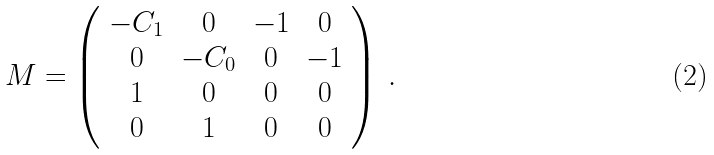Convert formula to latex. <formula><loc_0><loc_0><loc_500><loc_500>M = \left ( \begin{array} { c c c c } - C _ { 1 } & 0 & - 1 & 0 \\ 0 & - C _ { 0 } & 0 & - 1 \\ 1 & 0 & 0 & 0 \\ 0 & 1 & 0 & 0 \\ \end{array} \right ) \, .</formula> 